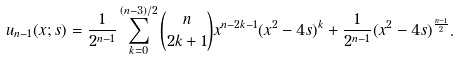<formula> <loc_0><loc_0><loc_500><loc_500>u _ { n - 1 } ( x ; s ) = \frac { 1 } { 2 ^ { n - 1 } } \sum _ { k = 0 } ^ { ( n - 3 ) / 2 } \binom { n } { 2 k + 1 } x ^ { n - 2 k - 1 } ( x ^ { 2 } - 4 s ) ^ { k } + \frac { 1 } { 2 ^ { n - 1 } } ( x ^ { 2 } - 4 s ) ^ { \frac { n - 1 } { 2 } } .</formula> 